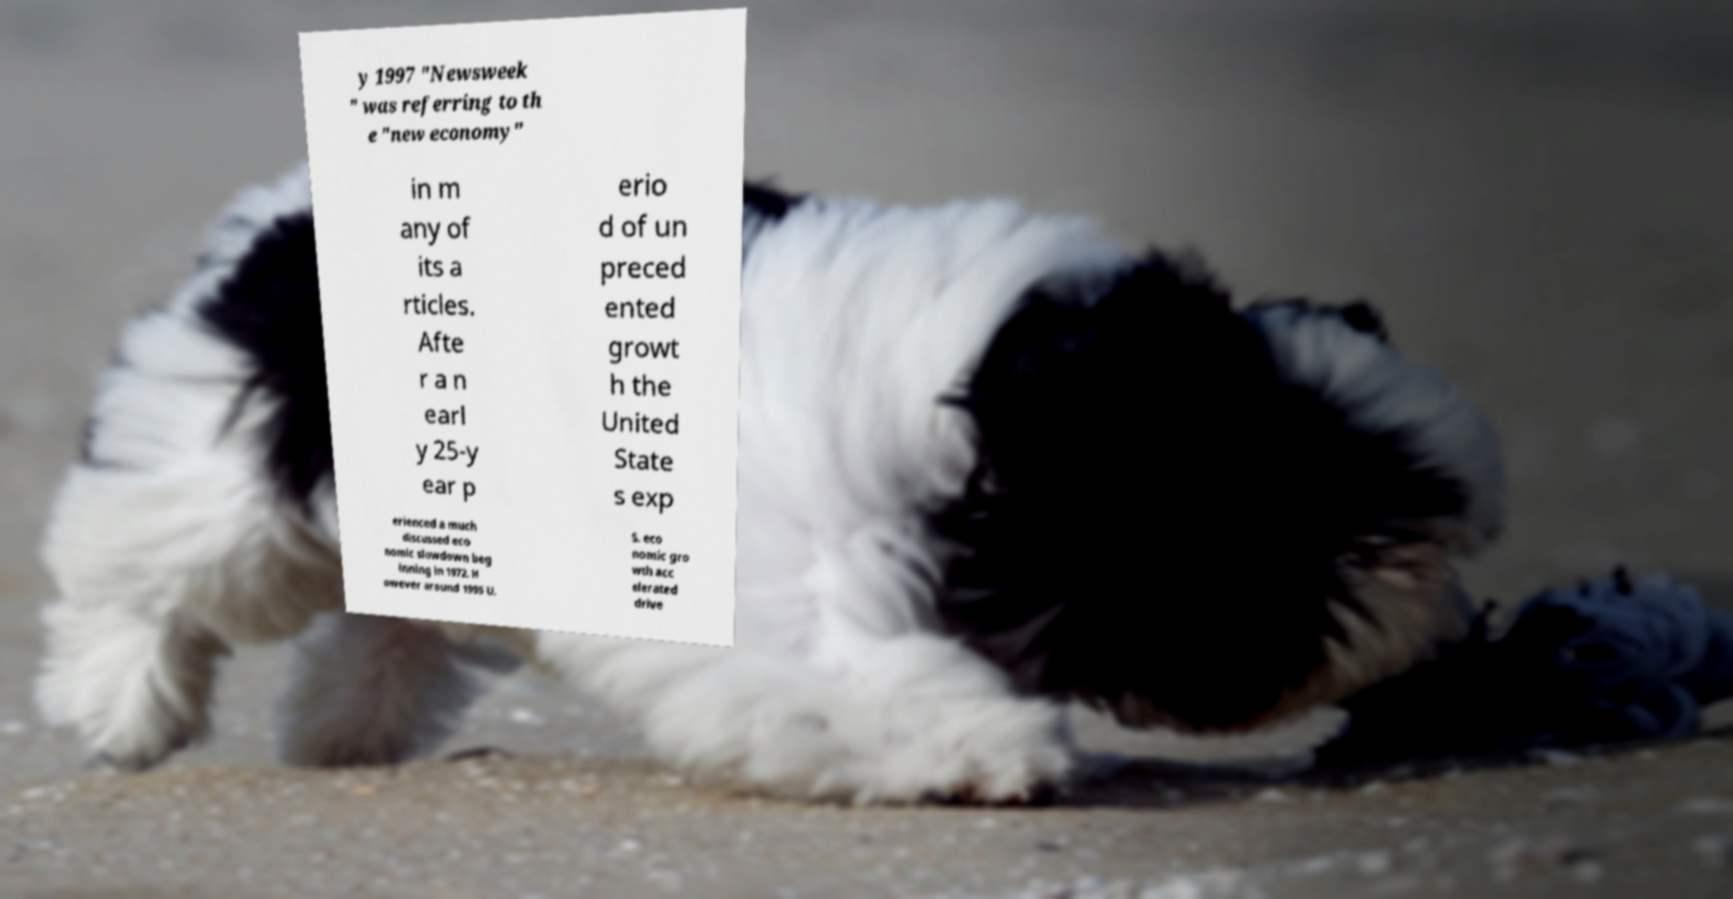Could you assist in decoding the text presented in this image and type it out clearly? y 1997 "Newsweek " was referring to th e "new economy" in m any of its a rticles. Afte r a n earl y 25-y ear p erio d of un preced ented growt h the United State s exp erienced a much discussed eco nomic slowdown beg inning in 1972. H owever around 1995 U. S. eco nomic gro wth acc elerated drive 